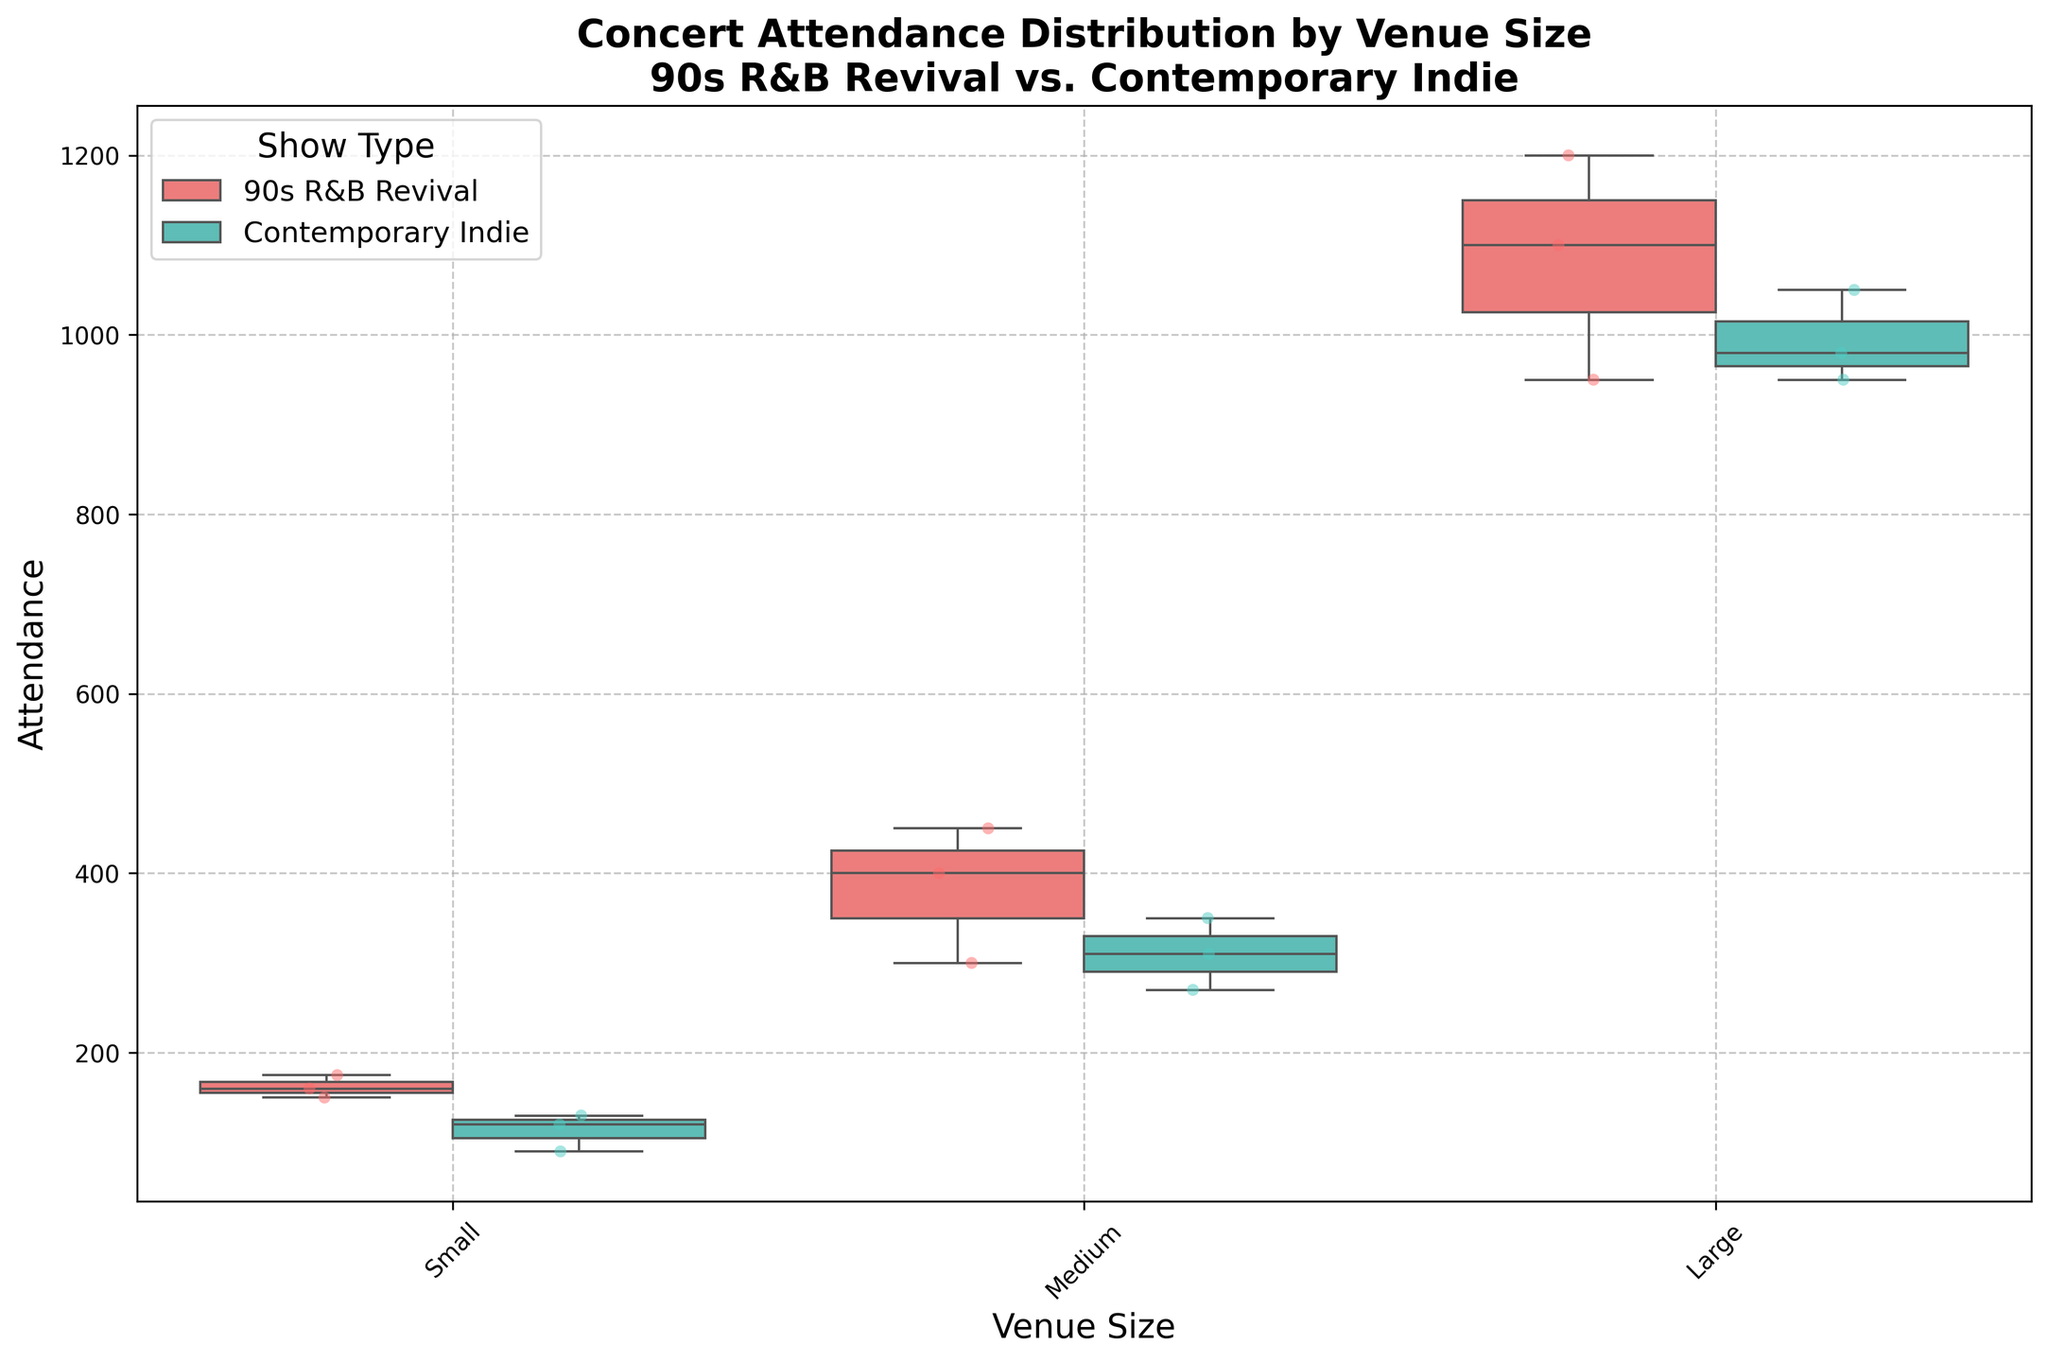What is the title of the plot? The title of the plot is typically at the top and summarizes the main focus. The title reads: "Concert Attendance Distribution by Venue Size\n90s R&B Revival vs. Contemporary Indie".
Answer: Concert Attendance Distribution by Venue Size\n90s R&B Revival vs. Contemporary Indie Which venue size generally has the highest attendance for 90s R&B Revival shows? By looking at the distribution for each venue size, the largest venues (Large) have generally higher attendance in the box plot for 90s R&B Revival shows.
Answer: Large What's the median attendance for Contemporary Indie shows in medium-sized venues? To find the median, look at the line inside the box for Contemporary Indie shows in the medium venue size. The line represents the median attendance.
Answer: 310 How does the attendance of small venues compare between 90s R&B Revival shows and Contemporary Indie shows? Compare the box plots for each group in the "Small" category. The 90s R&B Revival shows have a higher median and larger interquartile range compared to Contemporary Indie shows.
Answer: The median is higher for 90s R&B Revival shows What is the general range of attendance for large venues hosting 90s R&B Revival shows? The range is represented by the ends of the whiskers. The range for 90s R&B Revival shows in large venues is from 950 to 1200.
Answer: 950 to 1200 Which show type has a more consistent attendance in small venues? Consistency can be determined by the interquartile range. For small venues, Contemporary Indie shows have a narrower box plot, indicating more consistent attendance.
Answer: Contemporary Indie What can you infer about the attendance for medium-sized venues when comparing both show types? Look at both box plots for medium venues. The 90s R&B Revival shows generally have a higher median attendance compared to Contemporary Indie shows, and there is a wider spread for 90s R&B Revival.
Answer: 90s R&B Revival shows have a higher median and wider spread What is the interquartile range (IQR) for 90s R&B Revival shows in medium-sized venues? The IQR is the difference between the third quartile (upper edge of the box) and the first quartile (lower edge of the box). For the 90s R&B Revival shows in medium venues, the IQR is from around 300 to 450.
Answer: 150 Which show type and venue size combination has the lowest minimum attendance in the plot? Look at the lowest points at the end of the whiskers for each grouping. The smallest value appears in small venues for Contemporary Indie shows.
Answer: Contemporary Indie in small venues Which show type generally attracts larger audiences in large venues? Compare the box plots for "Large" venues. 90s R&B Revival shows generally attract larger audiences than Contemporary Indie shows in large venues, as indicated by their higher median and higher maximum values.
Answer: 90s R&B Revival 